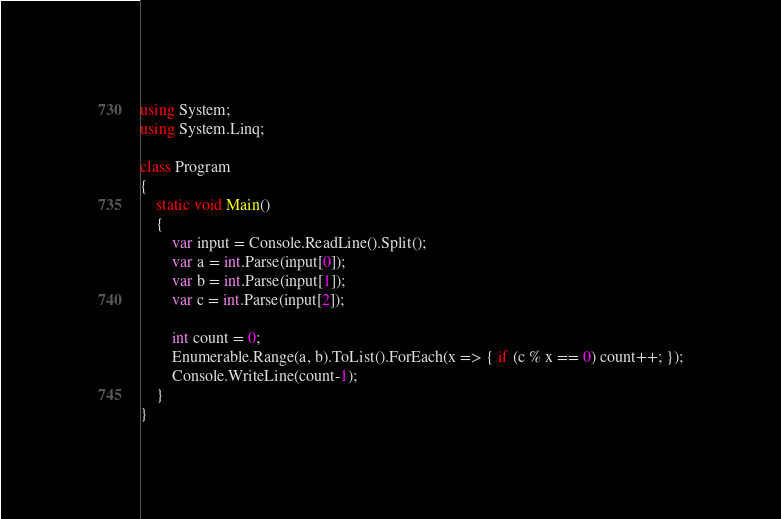<code> <loc_0><loc_0><loc_500><loc_500><_C#_>using System;
using System.Linq;

class Program
{
	static void Main()
	{
		var input = Console.ReadLine().Split();
		var a = int.Parse(input[0]);
		var b = int.Parse(input[1]);
		var c = int.Parse(input[2]);

		int count = 0;
		Enumerable.Range(a, b).ToList().ForEach(x => { if (c % x == 0) count++; });
		Console.WriteLine(count-1);
	}
}</code> 